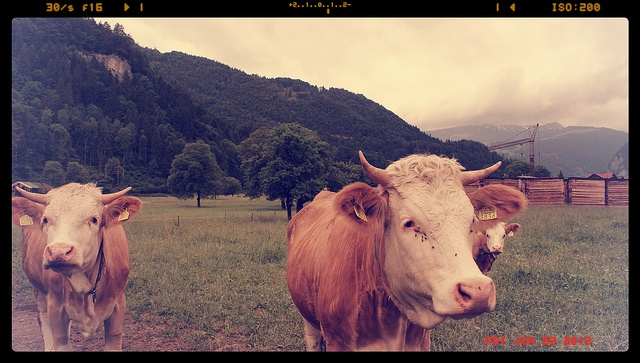Describe the objects in this image and their specific colors. I can see cow in black, brown, tan, purple, and salmon tones, cow in black, brown, tan, and purple tones, and cow in black, brown, tan, purple, and navy tones in this image. 